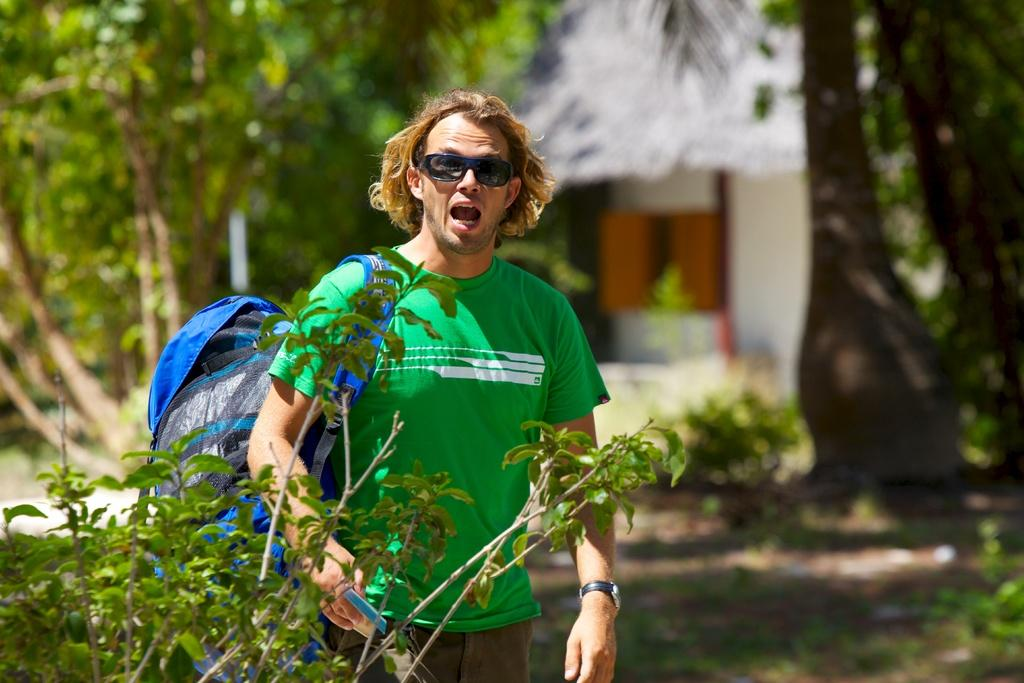Who or what is present in the image? There is a person in the image. What is the person wearing? The person is wearing a bag. What is in front of the person? There is a plant in front of the person. What can be seen in the background of the image? There are trees and a building in the background of the image. What type of van is parked next to the person in the image? There is no van present in the image; it only features a person, a plant, trees, and a building in the background. 